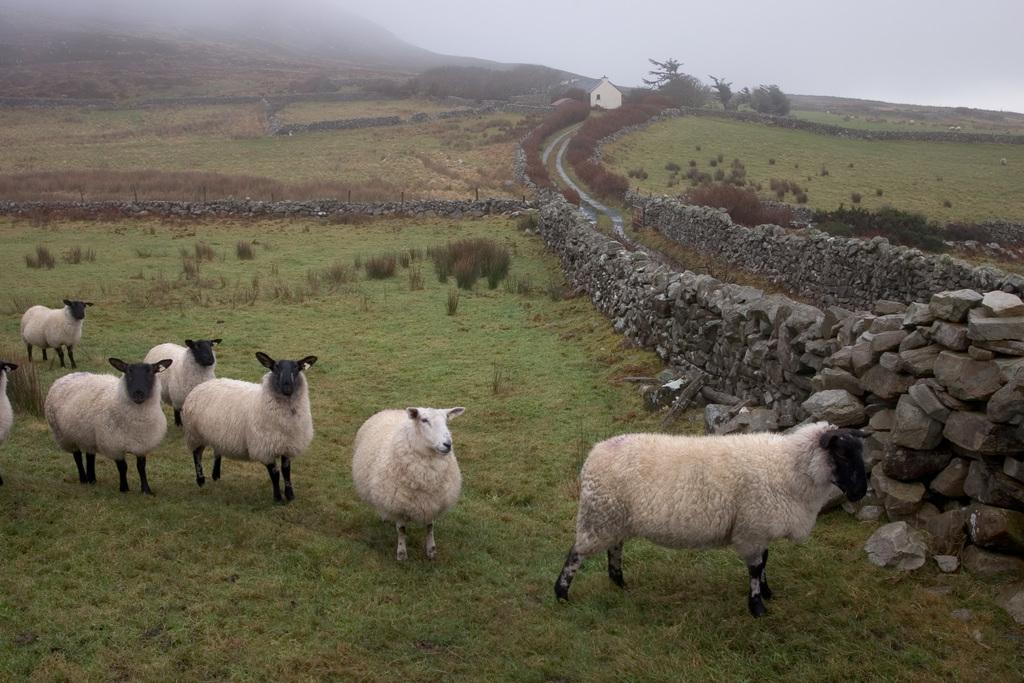What animals can be seen in the image? There are sheep in the image. What is behind the sheep in the image? There is a rock wall behind the sheep. What structures can be seen in the background of the image? There is a house in the background of the image. What type of vegetation is visible in the background of the image? Plants and trees are visible in the background of the image. What geographical feature is at the top of the image? There is a hill at the top of the image. What is visible at the top of the image? The sky is visible at the top of the image. What type of book can be seen in the hands of the sheep in the image? There are no books present in the image, and the sheep are not holding anything. 